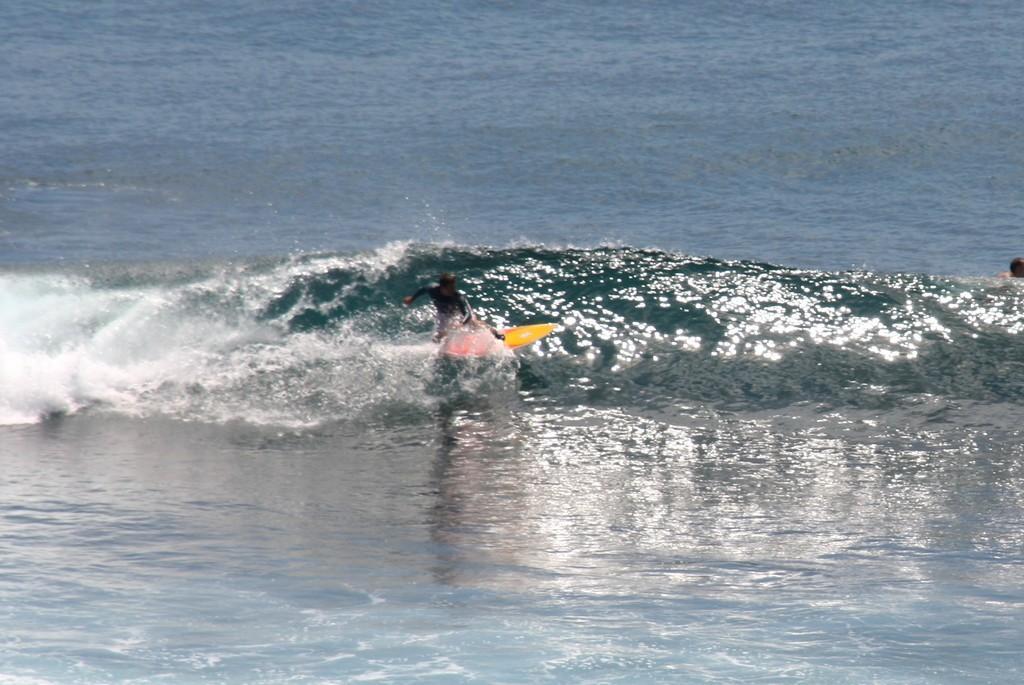Can you describe this image briefly? In this image there is a man on the surfing board, there is a man towards the right of the image, there is water, there is water wave. 